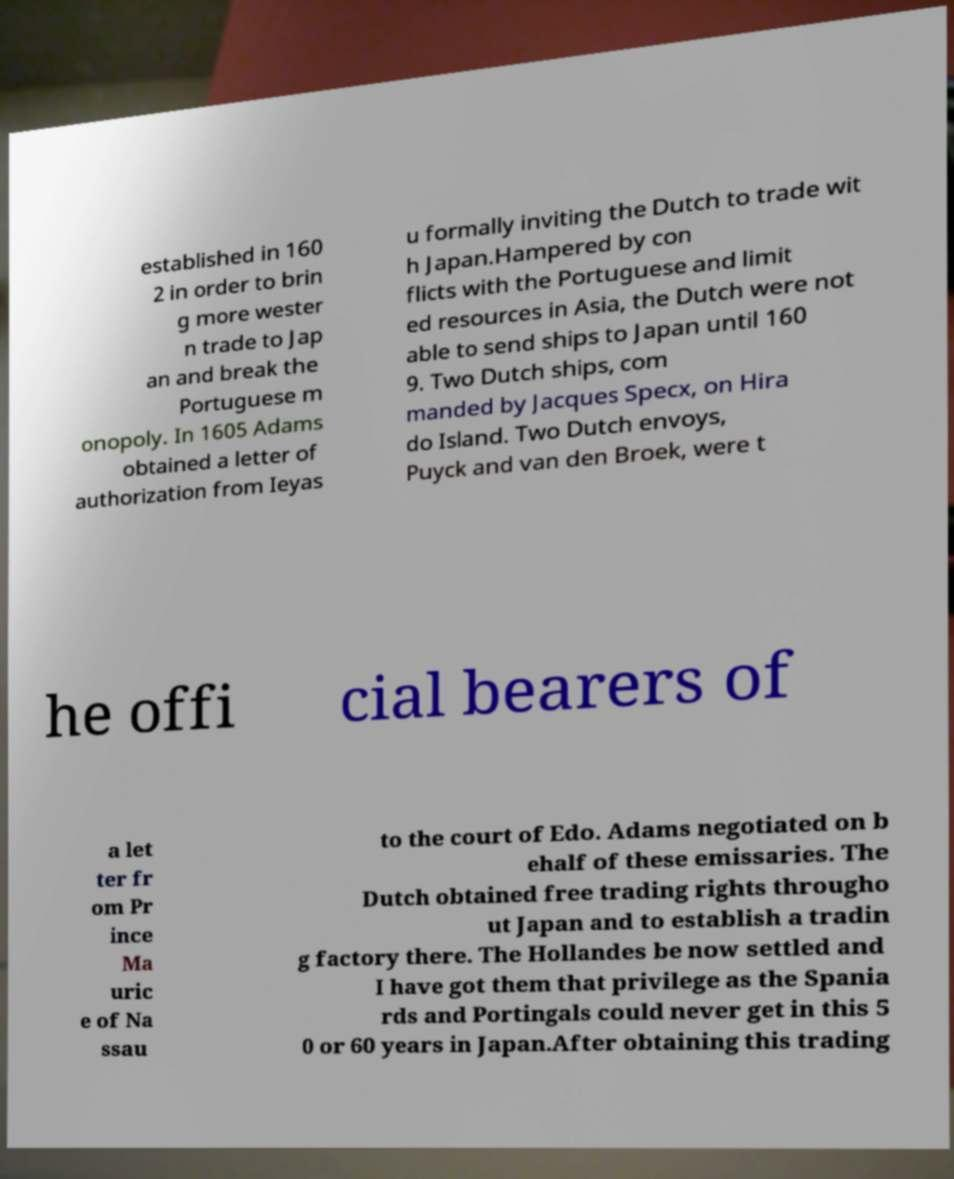Can you accurately transcribe the text from the provided image for me? established in 160 2 in order to brin g more wester n trade to Jap an and break the Portuguese m onopoly. In 1605 Adams obtained a letter of authorization from Ieyas u formally inviting the Dutch to trade wit h Japan.Hampered by con flicts with the Portuguese and limit ed resources in Asia, the Dutch were not able to send ships to Japan until 160 9. Two Dutch ships, com manded by Jacques Specx, on Hira do Island. Two Dutch envoys, Puyck and van den Broek, were t he offi cial bearers of a let ter fr om Pr ince Ma uric e of Na ssau to the court of Edo. Adams negotiated on b ehalf of these emissaries. The Dutch obtained free trading rights througho ut Japan and to establish a tradin g factory there. The Hollandes be now settled and I have got them that privilege as the Spania rds and Portingals could never get in this 5 0 or 60 years in Japan.After obtaining this trading 